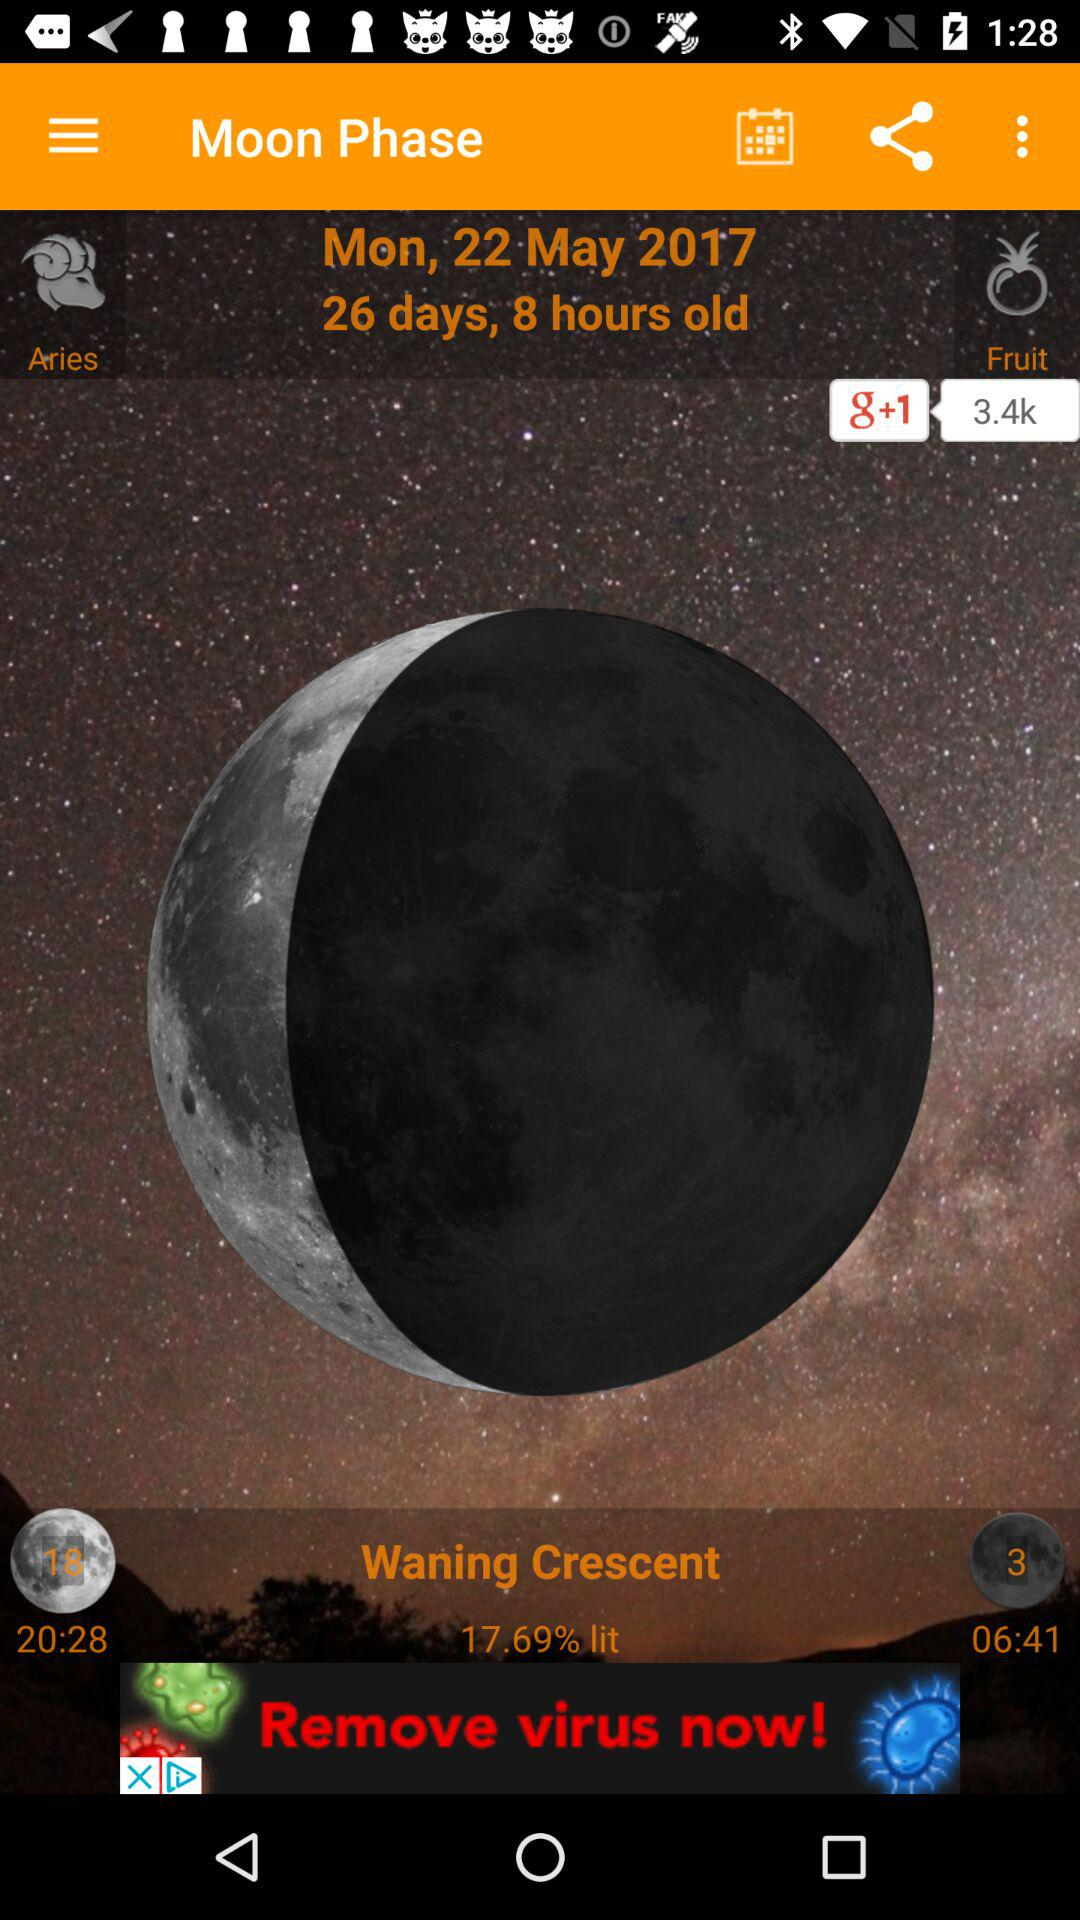What is the Zodiac sign? The Zodiac sign is Aries. 